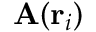<formula> <loc_0><loc_0><loc_500><loc_500>A ( r _ { i } )</formula> 